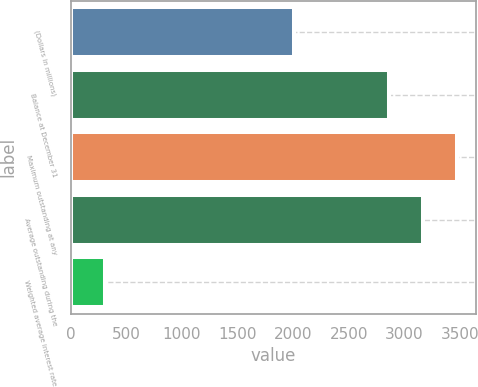<chart> <loc_0><loc_0><loc_500><loc_500><bar_chart><fcel>(Dollars in millions)<fcel>Balance at December 31<fcel>Maximum outstanding at any<fcel>Average outstanding during the<fcel>Weighted average interest rate<nl><fcel>2008<fcel>2858<fcel>3471.04<fcel>3164.52<fcel>309.32<nl></chart> 